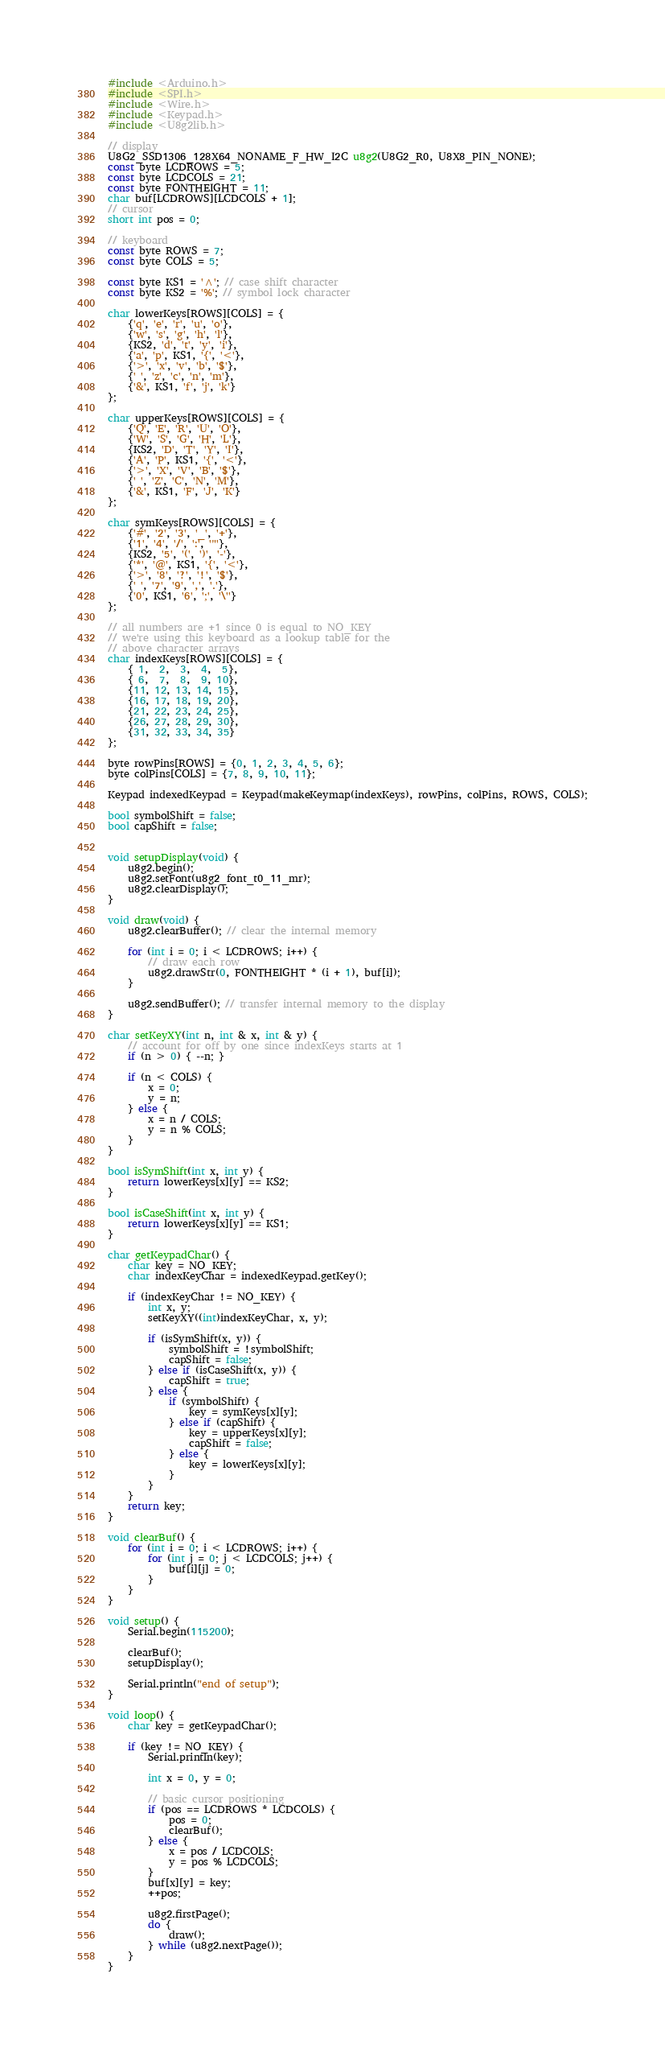<code> <loc_0><loc_0><loc_500><loc_500><_C++_>#include <Arduino.h>
#include <SPI.h>
#include <Wire.h>
#include <Keypad.h>
#include <U8g2lib.h>

// display
U8G2_SSD1306_128X64_NONAME_F_HW_I2C u8g2(U8G2_R0, U8X8_PIN_NONE);
const byte LCDROWS = 5;
const byte LCDCOLS = 21;
const byte FONTHEIGHT = 11;
char buf[LCDROWS][LCDCOLS + 1];
// cursor
short int pos = 0;

// keyboard
const byte ROWS = 7;
const byte COLS = 5;

const byte KS1 = '^'; // case shift character
const byte KS2 = '%'; // symbol lock character

char lowerKeys[ROWS][COLS] = {
    {'q', 'e', 'r', 'u', 'o'},
    {'w', 's', 'g', 'h', 'l'},
    {KS2, 'd', 't', 'y', 'i'},
    {'a', 'p', KS1, '{', '<'},
    {'>', 'x', 'v', 'b', '$'},
    {' ', 'z', 'c', 'n', 'm'},
    {'&', KS1, 'f', 'j', 'k'}
};

char upperKeys[ROWS][COLS] = {
    {'Q', 'E', 'R', 'U', 'O'},
    {'W', 'S', 'G', 'H', 'L'},
    {KS2, 'D', 'T', 'Y', 'I'},
    {'A', 'P', KS1, '{', '<'},
    {'>', 'X', 'V', 'B', '$'},
    {' ', 'Z', 'C', 'N', 'M'},
    {'&', KS1, 'F', 'J', 'K'}
};

char symKeys[ROWS][COLS] = {
    {'#', '2', '3', '_', '+'},
    {'1', '4', '/', ':', '"'},
    {KS2, '5', '(', ')', '-'},
    {'*', '@', KS1, '{', '<'},
    {'>', '8', '?', '!', '$'},
    {' ', '7', '9', ',', '.'},
    {'0', KS1, '6', ';', '\''}
};

// all numbers are +1 since 0 is equal to NO_KEY
// we're using this keyboard as a lookup table for the
// above character arrays
char indexKeys[ROWS][COLS] = {
    { 1,  2,  3,  4,  5},
    { 6,  7,  8,  9, 10},
    {11, 12, 13, 14, 15},
    {16, 17, 18, 19, 20},
    {21, 22, 23, 24, 25},
    {26, 27, 28, 29, 30},
    {31, 32, 33, 34, 35}
};

byte rowPins[ROWS] = {0, 1, 2, 3, 4, 5, 6};
byte colPins[COLS] = {7, 8, 9, 10, 11};

Keypad indexedKeypad = Keypad(makeKeymap(indexKeys), rowPins, colPins, ROWS, COLS);

bool symbolShift = false;
bool capShift = false;


void setupDisplay(void) {
    u8g2.begin();
    u8g2.setFont(u8g2_font_t0_11_mr);
    u8g2.clearDisplay();
}

void draw(void) {
    u8g2.clearBuffer(); // clear the internal memory

    for (int i = 0; i < LCDROWS; i++) {
        // draw each row
        u8g2.drawStr(0, FONTHEIGHT * (i + 1), buf[i]);
    }

    u8g2.sendBuffer(); // transfer internal memory to the display
}

char setKeyXY(int n, int & x, int & y) {
    // account for off by one since indexKeys starts at 1
    if (n > 0) { --n; }

    if (n < COLS) {
        x = 0;
        y = n;
    } else {
        x = n / COLS;
        y = n % COLS;
    }
}

bool isSymShift(int x, int y) {
    return lowerKeys[x][y] == KS2;
}

bool isCaseShift(int x, int y) {
    return lowerKeys[x][y] == KS1;
}

char getKeypadChar() {
    char key = NO_KEY;
    char indexKeyChar = indexedKeypad.getKey();

    if (indexKeyChar != NO_KEY) {
        int x, y;
        setKeyXY((int)indexKeyChar, x, y);

        if (isSymShift(x, y)) {
            symbolShift = !symbolShift;
            capShift = false;
        } else if (isCaseShift(x, y)) {
            capShift = true;
        } else {
            if (symbolShift) {
                key = symKeys[x][y];
            } else if (capShift) {
                key = upperKeys[x][y];
                capShift = false;
            } else {
                key = lowerKeys[x][y];
            }
        }
    }
    return key;
}

void clearBuf() {
    for (int i = 0; i < LCDROWS; i++) {
        for (int j = 0; j < LCDCOLS; j++) {
            buf[i][j] = 0;
        }
    }
}

void setup() {
    Serial.begin(115200);

    clearBuf();
    setupDisplay();

    Serial.println("end of setup");
}

void loop() {
    char key = getKeypadChar();

    if (key != NO_KEY) {
        Serial.println(key);

        int x = 0, y = 0;

        // basic cursor positioning
        if (pos == LCDROWS * LCDCOLS) {
            pos = 0;
            clearBuf();
        } else {
            x = pos / LCDCOLS;
            y = pos % LCDCOLS;
        }
        buf[x][y] = key;
        ++pos;

        u8g2.firstPage();
        do {
            draw();
        } while (u8g2.nextPage());
    }
}
</code> 